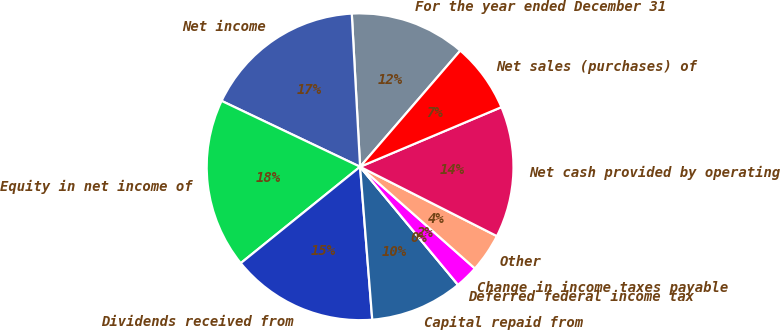Convert chart to OTSL. <chart><loc_0><loc_0><loc_500><loc_500><pie_chart><fcel>For the year ended December 31<fcel>Net income<fcel>Equity in net income of<fcel>Dividends received from<fcel>Capital repaid from<fcel>Deferred federal income tax<fcel>Change in income taxes payable<fcel>Other<fcel>Net cash provided by operating<fcel>Net sales (purchases) of<nl><fcel>12.19%<fcel>17.07%<fcel>17.88%<fcel>15.45%<fcel>9.76%<fcel>0.0%<fcel>2.44%<fcel>4.07%<fcel>13.82%<fcel>7.32%<nl></chart> 